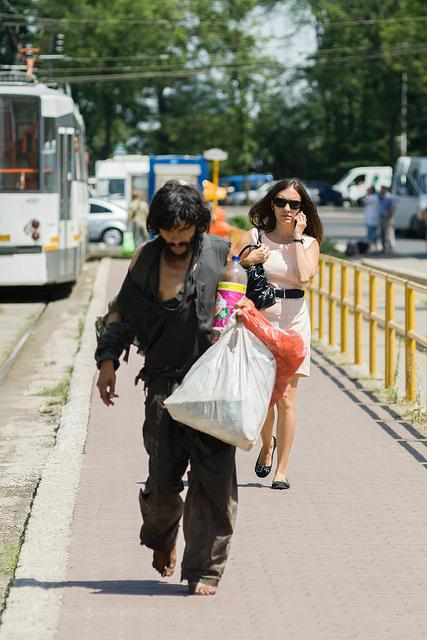What type of phone is the woman using? cellphone 